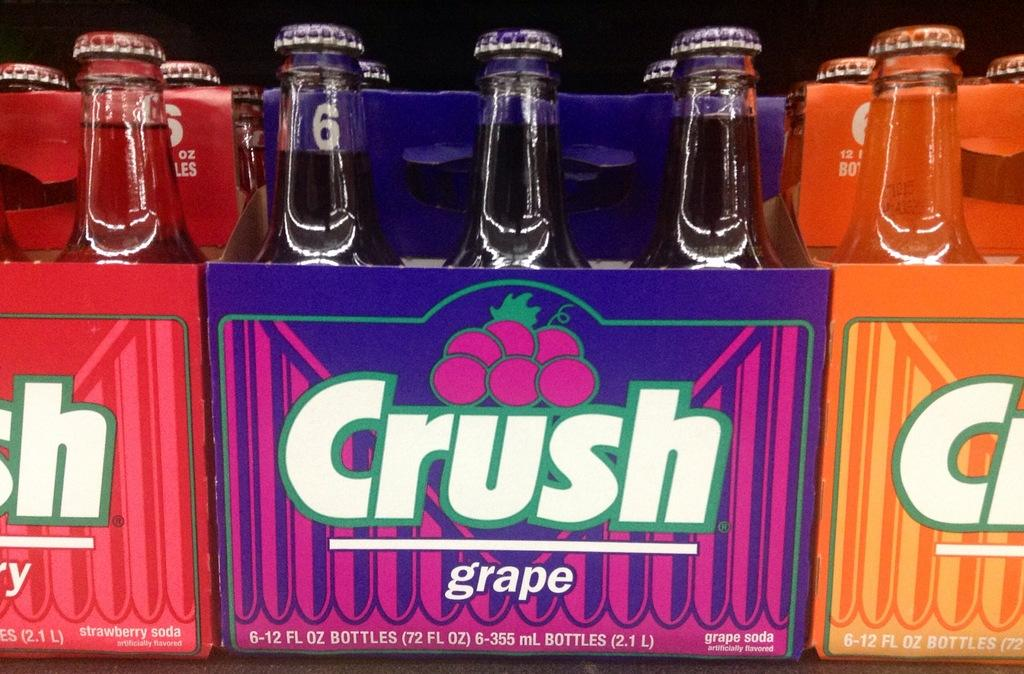Provide a one-sentence caption for the provided image. Packs of crush grape soda in a twelve ounce bottle. 